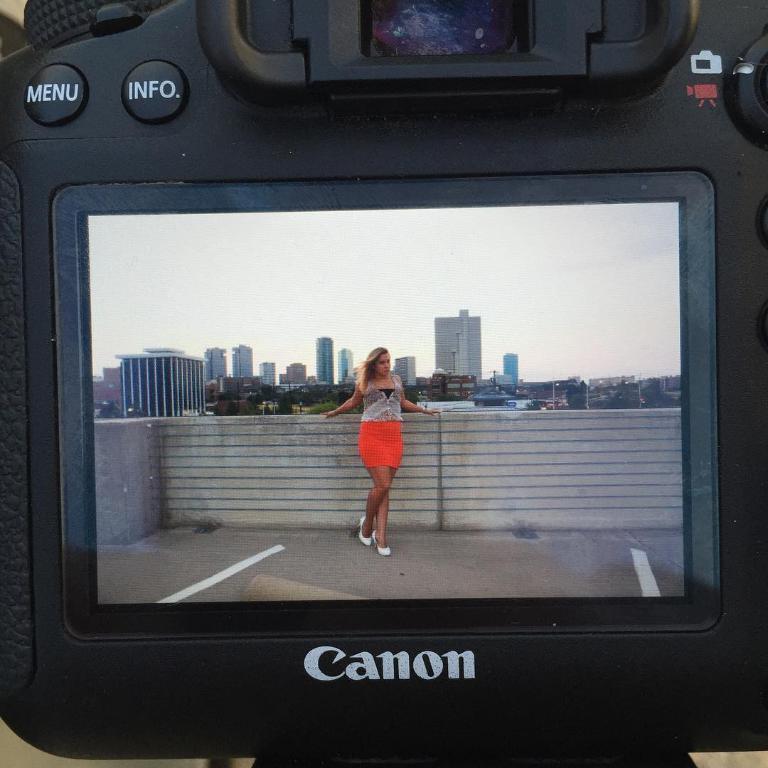Please provide a concise description of this image. In this picture there is a camera in the foreground and there is text on the camera. At the top there are buttons on the camera. On the screen, there is a woman standing at the wall and there are buildings and trees and poles. At the top there is sky. At the bottom there is a floor. 